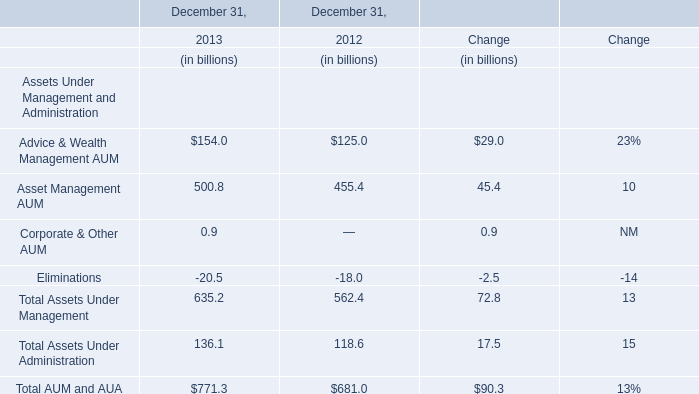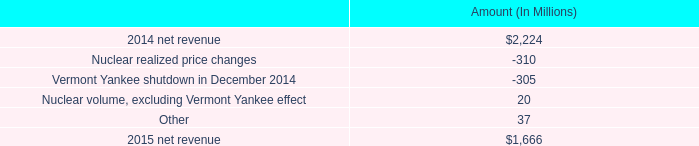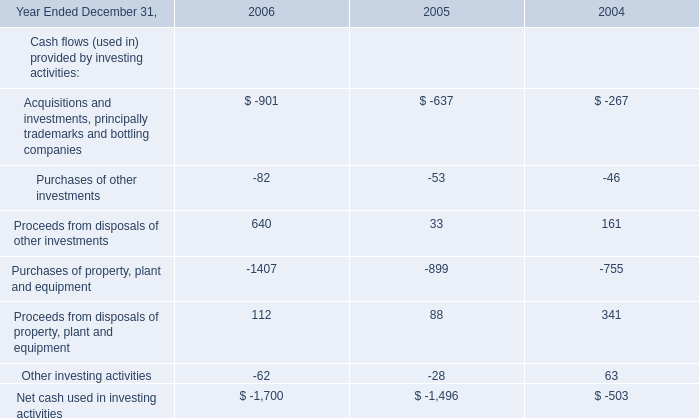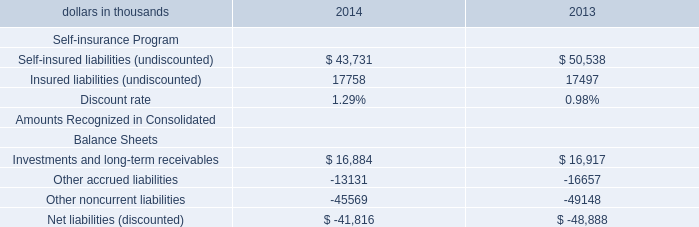Which year is Advice & Wealth Management AUM the highest for December 31, ? 
Answer: 2013. 